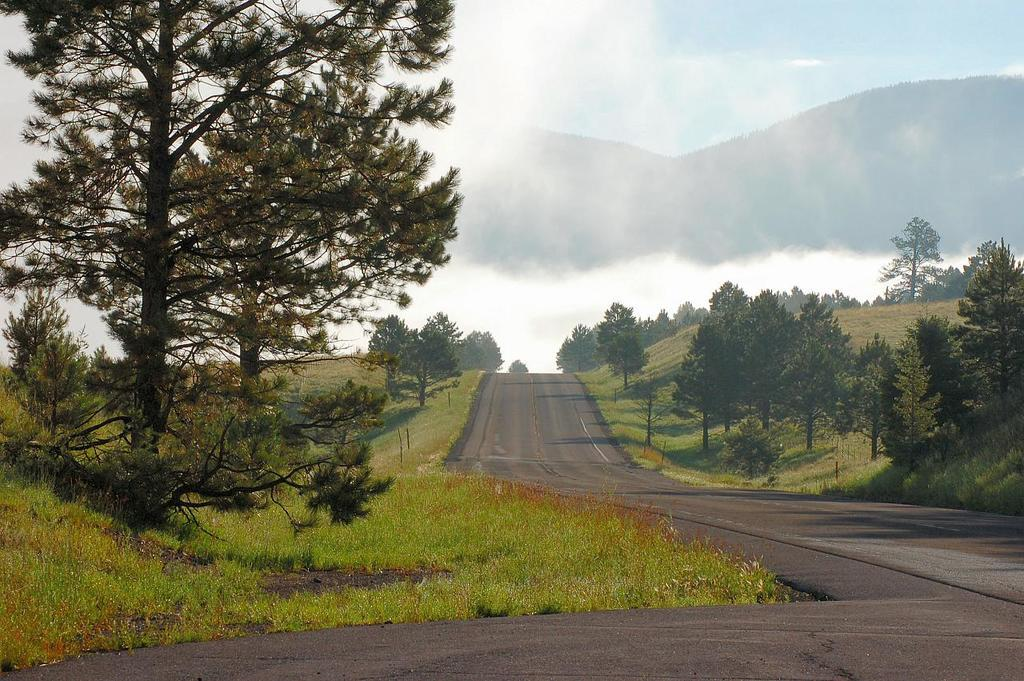What is the main feature of the image? There is a road in the image. What can be seen on either side of the road? There are trees on both the right and left sides of the road. How would you describe the sky in the image? The sky is cloudy in the image. Where is the nest located in the image? There is no nest present in the image. What type of knowledge is being shared in the image? There is no knowledge being shared in the image; it is a picture of a road with trees on either side and a cloudy sky. 